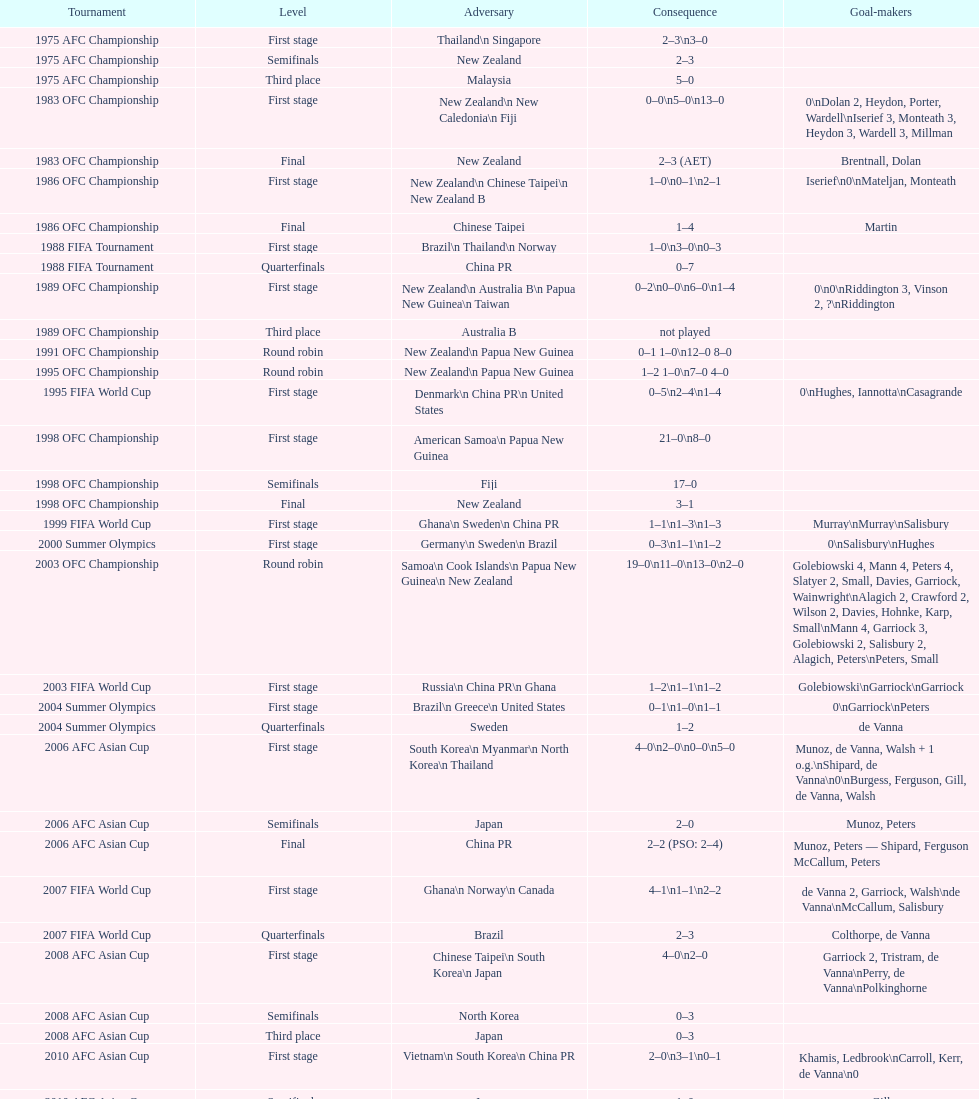Who was the last opponent this team faced in the 2010 afc asian cup? North Korea. 